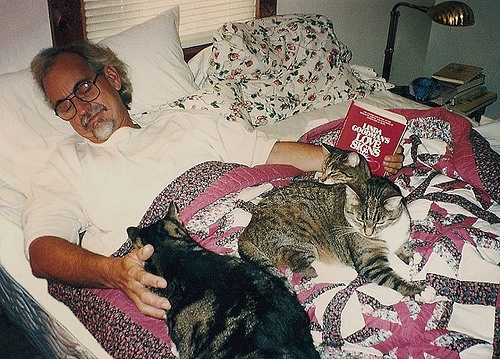Describe the objects in this image and their specific colors. I can see bed in gray, darkgray, lightgray, and black tones, people in gray, lightgray, maroon, and tan tones, cat in gray, black, darkgreen, and darkgray tones, cat in gray, black, darkgreen, and darkgray tones, and book in gray, brown, white, maroon, and pink tones in this image. 